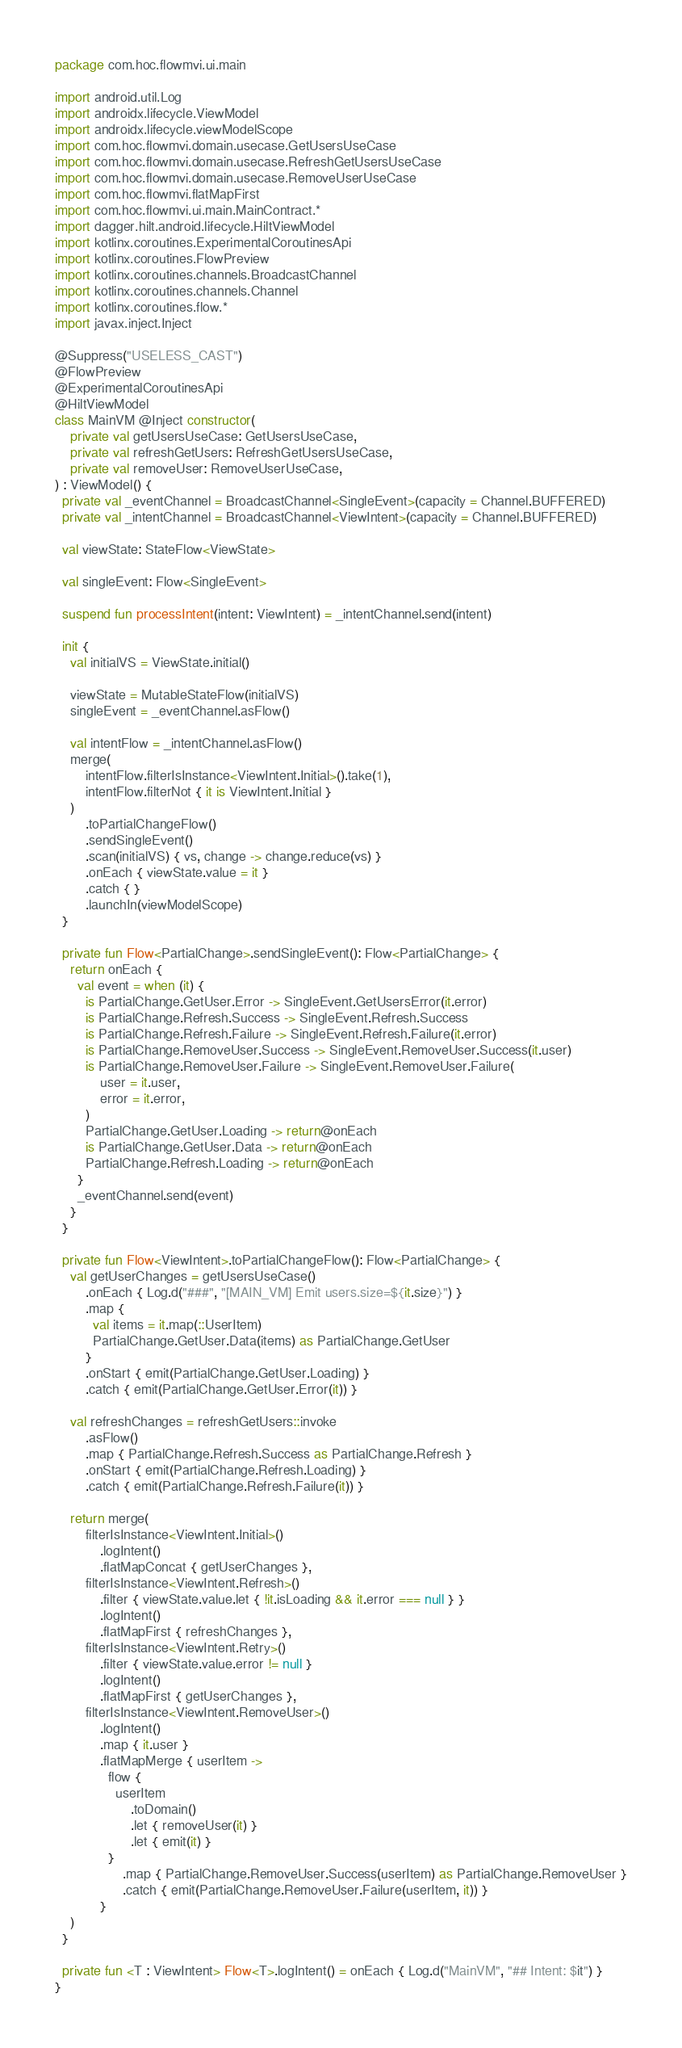<code> <loc_0><loc_0><loc_500><loc_500><_Kotlin_>package com.hoc.flowmvi.ui.main

import android.util.Log
import androidx.lifecycle.ViewModel
import androidx.lifecycle.viewModelScope
import com.hoc.flowmvi.domain.usecase.GetUsersUseCase
import com.hoc.flowmvi.domain.usecase.RefreshGetUsersUseCase
import com.hoc.flowmvi.domain.usecase.RemoveUserUseCase
import com.hoc.flowmvi.flatMapFirst
import com.hoc.flowmvi.ui.main.MainContract.*
import dagger.hilt.android.lifecycle.HiltViewModel
import kotlinx.coroutines.ExperimentalCoroutinesApi
import kotlinx.coroutines.FlowPreview
import kotlinx.coroutines.channels.BroadcastChannel
import kotlinx.coroutines.channels.Channel
import kotlinx.coroutines.flow.*
import javax.inject.Inject

@Suppress("USELESS_CAST")
@FlowPreview
@ExperimentalCoroutinesApi
@HiltViewModel
class MainVM @Inject constructor(
    private val getUsersUseCase: GetUsersUseCase,
    private val refreshGetUsers: RefreshGetUsersUseCase,
    private val removeUser: RemoveUserUseCase,
) : ViewModel() {
  private val _eventChannel = BroadcastChannel<SingleEvent>(capacity = Channel.BUFFERED)
  private val _intentChannel = BroadcastChannel<ViewIntent>(capacity = Channel.BUFFERED)

  val viewState: StateFlow<ViewState>

  val singleEvent: Flow<SingleEvent>

  suspend fun processIntent(intent: ViewIntent) = _intentChannel.send(intent)

  init {
    val initialVS = ViewState.initial()

    viewState = MutableStateFlow(initialVS)
    singleEvent = _eventChannel.asFlow()

    val intentFlow = _intentChannel.asFlow()
    merge(
        intentFlow.filterIsInstance<ViewIntent.Initial>().take(1),
        intentFlow.filterNot { it is ViewIntent.Initial }
    )
        .toPartialChangeFlow()
        .sendSingleEvent()
        .scan(initialVS) { vs, change -> change.reduce(vs) }
        .onEach { viewState.value = it }
        .catch { }
        .launchIn(viewModelScope)
  }

  private fun Flow<PartialChange>.sendSingleEvent(): Flow<PartialChange> {
    return onEach {
      val event = when (it) {
        is PartialChange.GetUser.Error -> SingleEvent.GetUsersError(it.error)
        is PartialChange.Refresh.Success -> SingleEvent.Refresh.Success
        is PartialChange.Refresh.Failure -> SingleEvent.Refresh.Failure(it.error)
        is PartialChange.RemoveUser.Success -> SingleEvent.RemoveUser.Success(it.user)
        is PartialChange.RemoveUser.Failure -> SingleEvent.RemoveUser.Failure(
            user = it.user,
            error = it.error,
        )
        PartialChange.GetUser.Loading -> return@onEach
        is PartialChange.GetUser.Data -> return@onEach
        PartialChange.Refresh.Loading -> return@onEach
      }
      _eventChannel.send(event)
    }
  }

  private fun Flow<ViewIntent>.toPartialChangeFlow(): Flow<PartialChange> {
    val getUserChanges = getUsersUseCase()
        .onEach { Log.d("###", "[MAIN_VM] Emit users.size=${it.size}") }
        .map {
          val items = it.map(::UserItem)
          PartialChange.GetUser.Data(items) as PartialChange.GetUser
        }
        .onStart { emit(PartialChange.GetUser.Loading) }
        .catch { emit(PartialChange.GetUser.Error(it)) }

    val refreshChanges = refreshGetUsers::invoke
        .asFlow()
        .map { PartialChange.Refresh.Success as PartialChange.Refresh }
        .onStart { emit(PartialChange.Refresh.Loading) }
        .catch { emit(PartialChange.Refresh.Failure(it)) }

    return merge(
        filterIsInstance<ViewIntent.Initial>()
            .logIntent()
            .flatMapConcat { getUserChanges },
        filterIsInstance<ViewIntent.Refresh>()
            .filter { viewState.value.let { !it.isLoading && it.error === null } }
            .logIntent()
            .flatMapFirst { refreshChanges },
        filterIsInstance<ViewIntent.Retry>()
            .filter { viewState.value.error != null }
            .logIntent()
            .flatMapFirst { getUserChanges },
        filterIsInstance<ViewIntent.RemoveUser>()
            .logIntent()
            .map { it.user }
            .flatMapMerge { userItem ->
              flow {
                userItem
                    .toDomain()
                    .let { removeUser(it) }
                    .let { emit(it) }
              }
                  .map { PartialChange.RemoveUser.Success(userItem) as PartialChange.RemoveUser }
                  .catch { emit(PartialChange.RemoveUser.Failure(userItem, it)) }
            }
    )
  }

  private fun <T : ViewIntent> Flow<T>.logIntent() = onEach { Log.d("MainVM", "## Intent: $it") }
}


</code> 